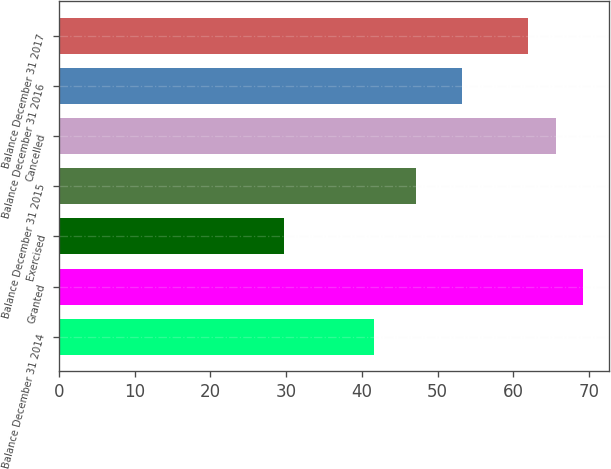Convert chart to OTSL. <chart><loc_0><loc_0><loc_500><loc_500><bar_chart><fcel>Balance December 31 2014<fcel>Granted<fcel>Exercised<fcel>Balance December 31 2015<fcel>Cancelled<fcel>Balance December 31 2016<fcel>Balance December 31 2017<nl><fcel>41.56<fcel>69.21<fcel>29.67<fcel>47.19<fcel>65.59<fcel>53.21<fcel>61.97<nl></chart> 